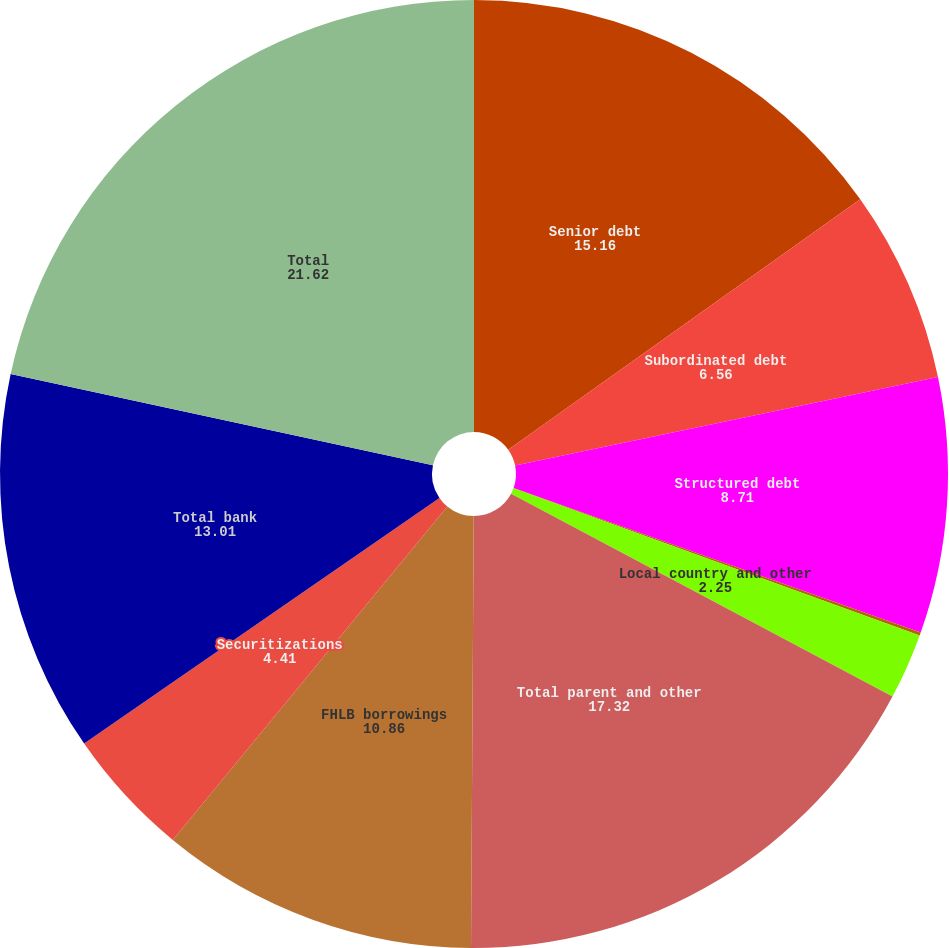Convert chart. <chart><loc_0><loc_0><loc_500><loc_500><pie_chart><fcel>Senior debt<fcel>Subordinated debt<fcel>Structured debt<fcel>Non-structured debt<fcel>Local country and other<fcel>Total parent and other<fcel>FHLB borrowings<fcel>Securitizations<fcel>Total bank<fcel>Total<nl><fcel>15.16%<fcel>6.56%<fcel>8.71%<fcel>0.1%<fcel>2.25%<fcel>17.32%<fcel>10.86%<fcel>4.41%<fcel>13.01%<fcel>21.62%<nl></chart> 